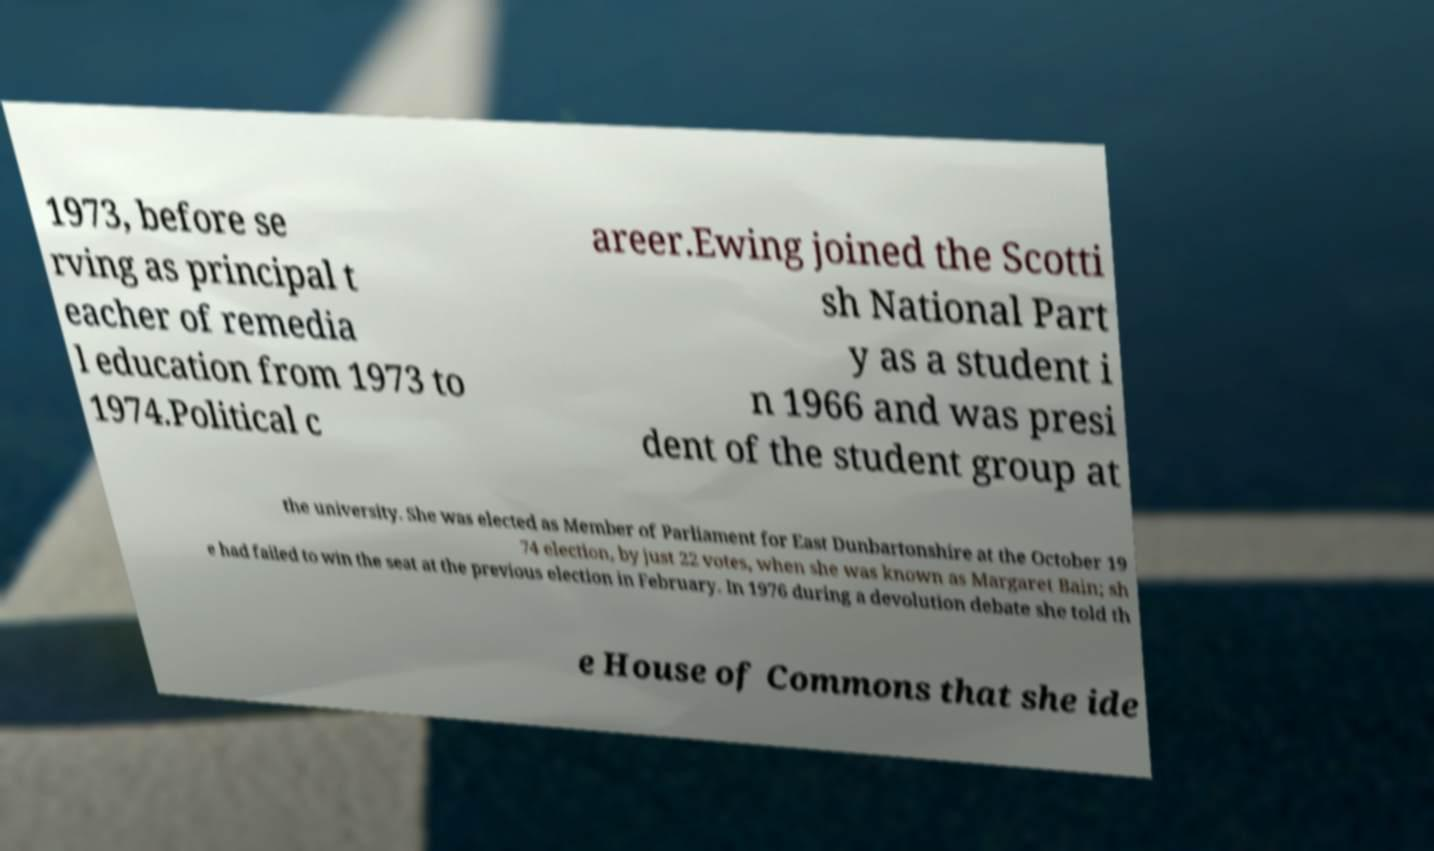Please read and relay the text visible in this image. What does it say? 1973, before se rving as principal t eacher of remedia l education from 1973 to 1974.Political c areer.Ewing joined the Scotti sh National Part y as a student i n 1966 and was presi dent of the student group at the university. She was elected as Member of Parliament for East Dunbartonshire at the October 19 74 election, by just 22 votes, when she was known as Margaret Bain; sh e had failed to win the seat at the previous election in February. In 1976 during a devolution debate she told th e House of Commons that she ide 